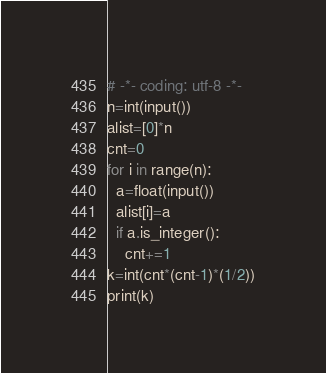<code> <loc_0><loc_0><loc_500><loc_500><_Python_># -*- coding: utf-8 -*-
n=int(input())
alist=[0]*n
cnt=0
for i in range(n):
  a=float(input())
  alist[i]=a
  if a.is_integer():
    cnt+=1
k=int(cnt*(cnt-1)*(1/2))
print(k)</code> 